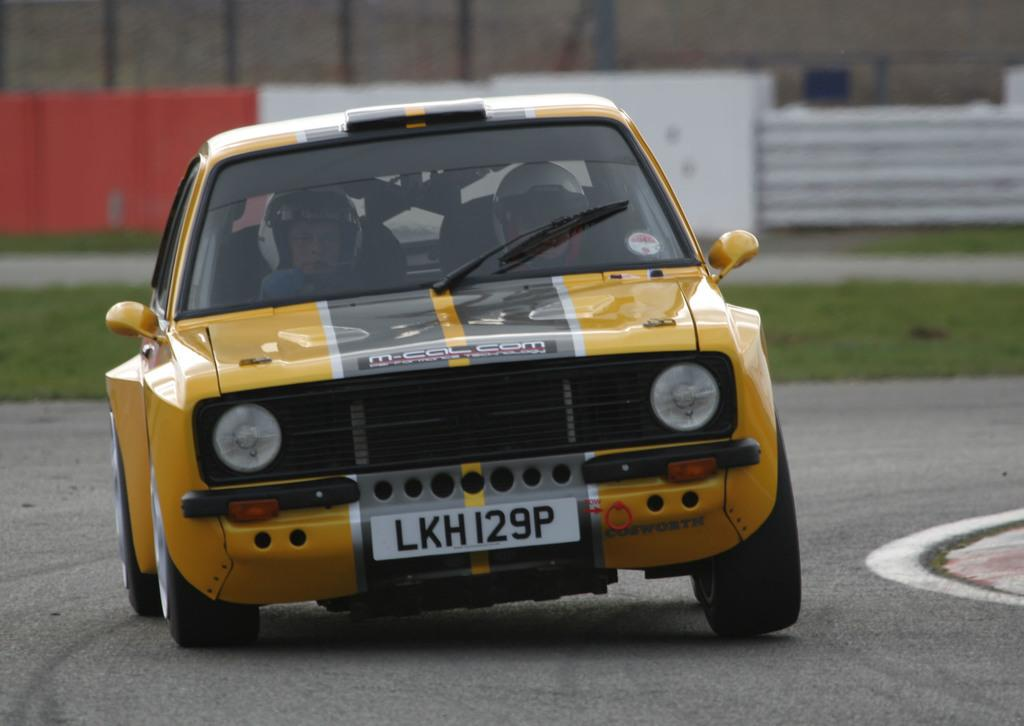What is on the road in the image? There is a car on the road in the image. Who is inside the car? There are two persons inside the car. What type of vegetation can be seen in the image? There is grass visible in the image. How would you describe the background of the image? The background of the image is blurred. What type of plate is being used to serve the salt in the image? There is no plate or salt present in the image. What type of spade is being used to dig in the grass in the image? There is no spade or digging activity present in the image. 